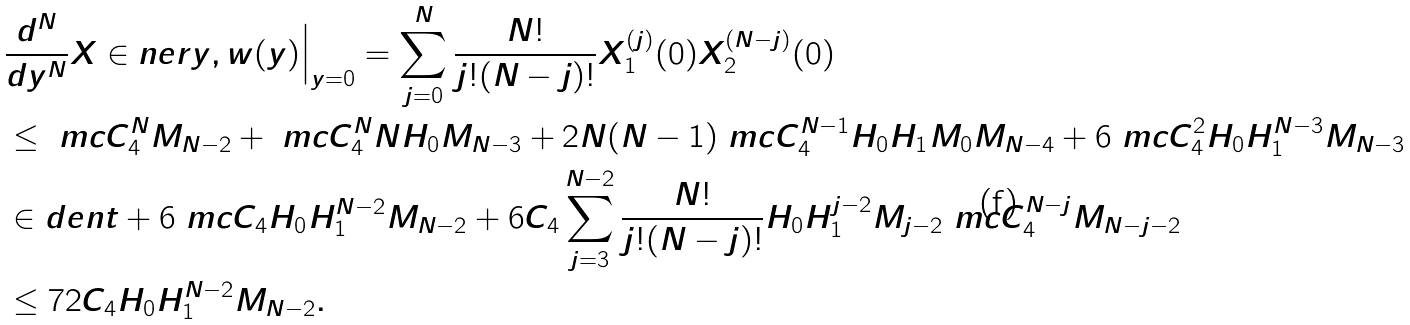<formula> <loc_0><loc_0><loc_500><loc_500>& \frac { d ^ { N } } { d y ^ { N } } X \in n e r { y , w ( y ) } \Big | _ { y = 0 } = \sum _ { j = 0 } ^ { N } \frac { N ! } { j ! ( N - j ) ! } X _ { 1 } ^ { ( j ) } ( 0 ) X _ { 2 } ^ { ( N - j ) } ( 0 ) \\ & \leq \ m c C _ { 4 } ^ { N } M _ { N - 2 } + \ m c C _ { 4 } ^ { N } N H _ { 0 } M _ { N - 3 } + 2 N ( N - 1 ) \ m c C _ { 4 } ^ { N - 1 } H _ { 0 } H _ { 1 } M _ { 0 } M _ { N - 4 } + 6 \ m c C _ { 4 } ^ { 2 } H _ { 0 } H _ { 1 } ^ { N - 3 } M _ { N - 3 } \\ & \in d e n t + 6 \ m c C _ { 4 } H _ { 0 } H _ { 1 } ^ { N - 2 } M _ { N - 2 } + 6 C _ { 4 } \sum _ { j = 3 } ^ { N - 2 } \frac { N ! } { j ! ( N - j ) ! } H _ { 0 } H _ { 1 } ^ { j - 2 } M _ { j - 2 } \ m c C _ { 4 } ^ { N - j } M _ { N - j - 2 } \\ & \leq 7 2 C _ { 4 } H _ { 0 } H _ { 1 } ^ { N - 2 } M _ { N - 2 } .</formula> 